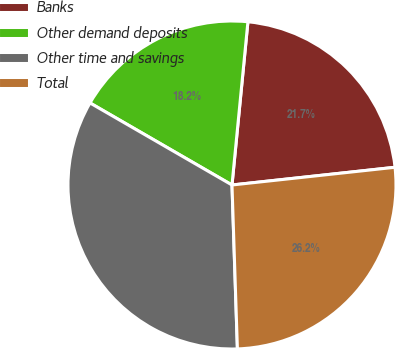<chart> <loc_0><loc_0><loc_500><loc_500><pie_chart><fcel>Banks<fcel>Other demand deposits<fcel>Other time and savings<fcel>Total<nl><fcel>21.73%<fcel>18.21%<fcel>33.87%<fcel>26.2%<nl></chart> 